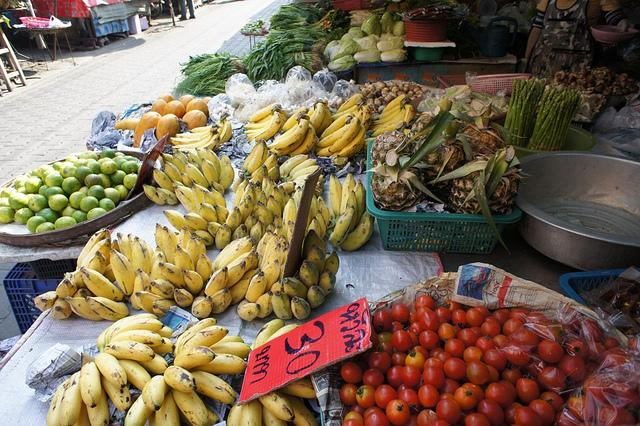What color are the sweet fruits? Please explain your reasoning. yellow. The pineapples and bananas are yellow. 